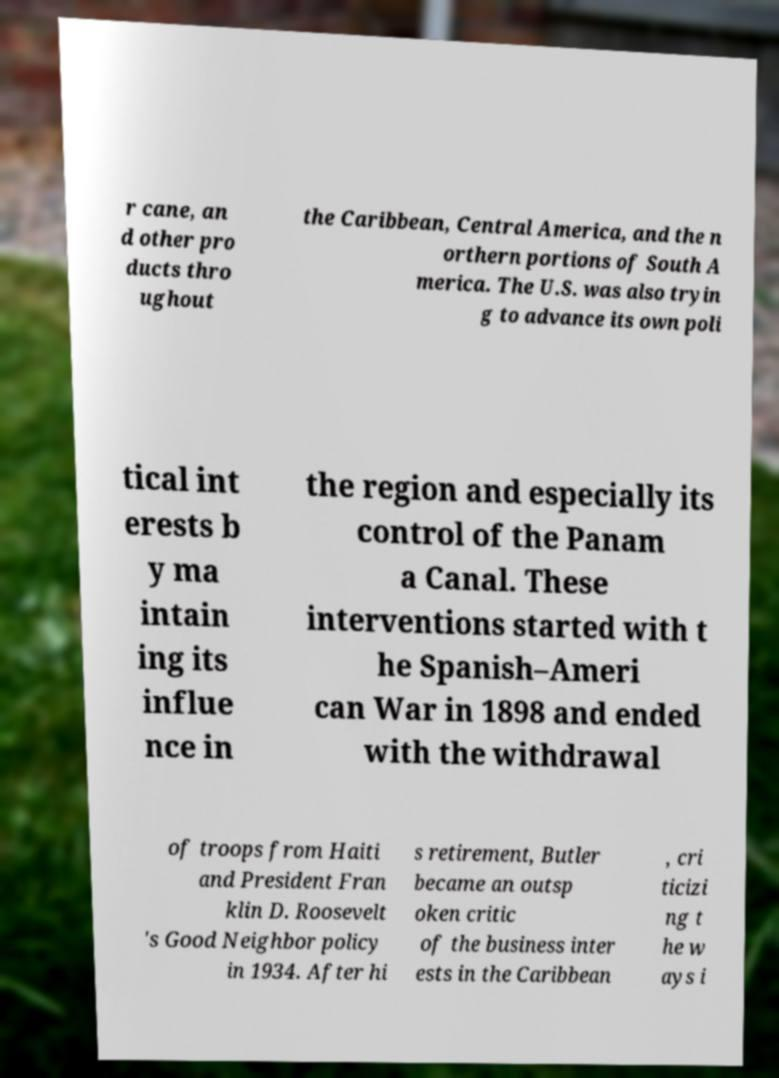I need the written content from this picture converted into text. Can you do that? r cane, an d other pro ducts thro ughout the Caribbean, Central America, and the n orthern portions of South A merica. The U.S. was also tryin g to advance its own poli tical int erests b y ma intain ing its influe nce in the region and especially its control of the Panam a Canal. These interventions started with t he Spanish–Ameri can War in 1898 and ended with the withdrawal of troops from Haiti and President Fran klin D. Roosevelt 's Good Neighbor policy in 1934. After hi s retirement, Butler became an outsp oken critic of the business inter ests in the Caribbean , cri ticizi ng t he w ays i 